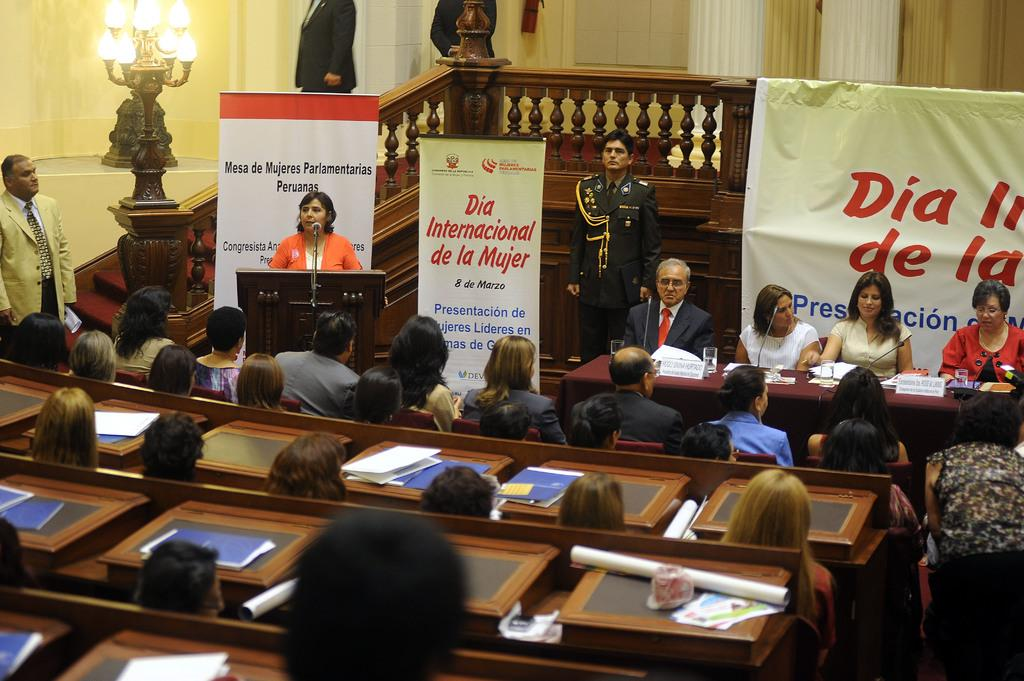Who or what can be seen in the image? There are people in the image. What is on the table in the image? There are objects on a table in the image. What architectural feature is visible in the background of the image? There are stairs visible in the background of the image. What can be seen providing illumination in the background of the image? There is a light visible in the background of the image. How many arms does the pan have in the image? There is no pan present in the image, so it is not possible to determine the number of arms it might have. 